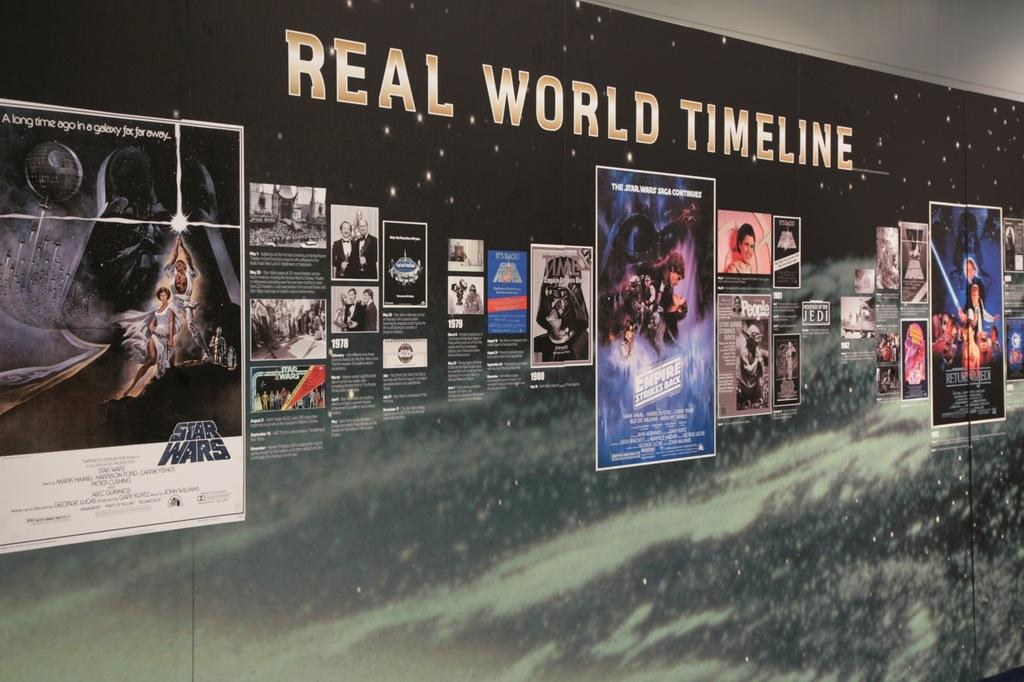<image>
Share a concise interpretation of the image provided. A poster featuring "Star Wars" movie art called "Real World Timeline" shows different Star Wars movie posters alongside each other. 